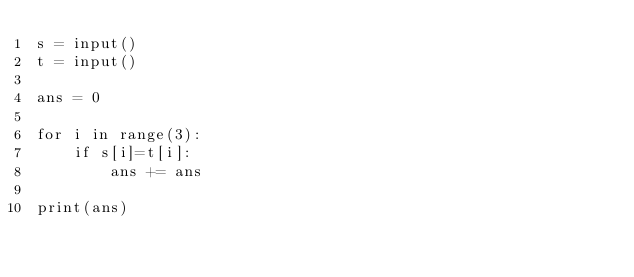<code> <loc_0><loc_0><loc_500><loc_500><_Python_>s = input() 
t = input()

ans = 0

for i in range(3):
	if s[i]=t[i]:
		ans += ans

print(ans)</code> 